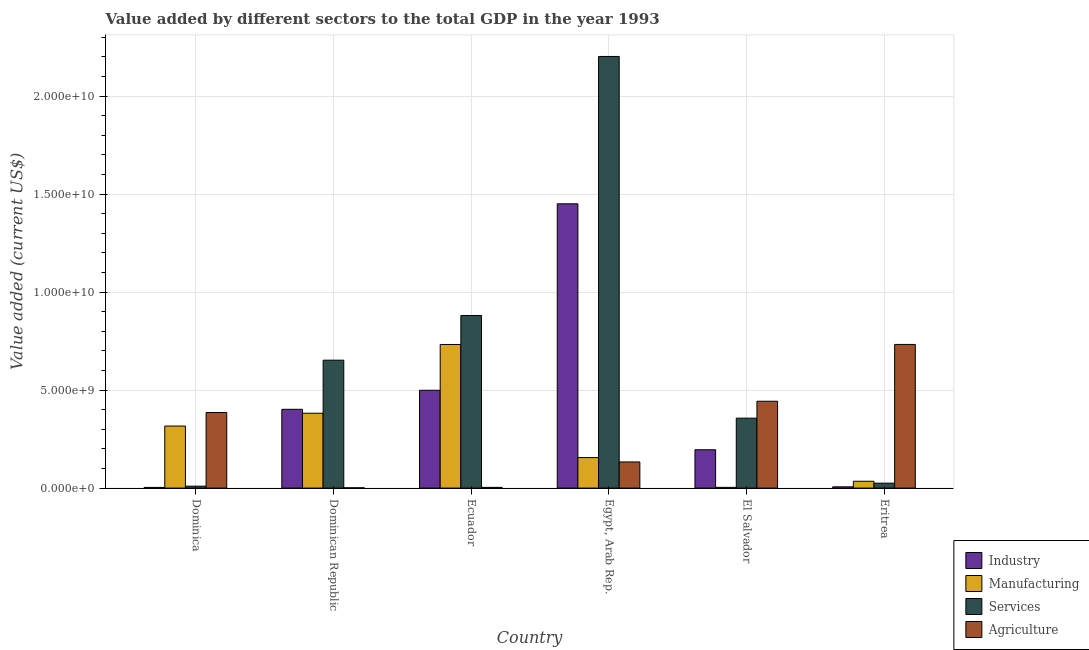How many groups of bars are there?
Offer a terse response. 6. Are the number of bars per tick equal to the number of legend labels?
Provide a short and direct response. Yes. Are the number of bars on each tick of the X-axis equal?
Your response must be concise. Yes. How many bars are there on the 3rd tick from the right?
Your answer should be very brief. 4. What is the label of the 4th group of bars from the left?
Your answer should be compact. Egypt, Arab Rep. In how many cases, is the number of bars for a given country not equal to the number of legend labels?
Your response must be concise. 0. What is the value added by industrial sector in Ecuador?
Provide a short and direct response. 4.99e+09. Across all countries, what is the maximum value added by industrial sector?
Keep it short and to the point. 1.45e+1. Across all countries, what is the minimum value added by industrial sector?
Keep it short and to the point. 3.49e+07. In which country was the value added by agricultural sector maximum?
Give a very brief answer. Eritrea. In which country was the value added by industrial sector minimum?
Provide a succinct answer. Dominica. What is the total value added by manufacturing sector in the graph?
Your answer should be very brief. 1.63e+1. What is the difference between the value added by agricultural sector in Egypt, Arab Rep. and that in Eritrea?
Ensure brevity in your answer.  -6.00e+09. What is the difference between the value added by agricultural sector in Dominica and the value added by manufacturing sector in Eritrea?
Provide a short and direct response. 3.51e+09. What is the average value added by manufacturing sector per country?
Your response must be concise. 2.71e+09. What is the difference between the value added by services sector and value added by agricultural sector in Egypt, Arab Rep.?
Provide a succinct answer. 2.07e+1. In how many countries, is the value added by industrial sector greater than 4000000000 US$?
Ensure brevity in your answer.  3. What is the ratio of the value added by agricultural sector in Dominican Republic to that in Ecuador?
Make the answer very short. 0.4. Is the value added by industrial sector in Ecuador less than that in El Salvador?
Make the answer very short. No. Is the difference between the value added by manufacturing sector in Ecuador and El Salvador greater than the difference between the value added by industrial sector in Ecuador and El Salvador?
Make the answer very short. Yes. What is the difference between the highest and the second highest value added by services sector?
Your answer should be compact. 1.32e+1. What is the difference between the highest and the lowest value added by industrial sector?
Give a very brief answer. 1.45e+1. Is it the case that in every country, the sum of the value added by industrial sector and value added by manufacturing sector is greater than the sum of value added by services sector and value added by agricultural sector?
Ensure brevity in your answer.  No. What does the 3rd bar from the left in Egypt, Arab Rep. represents?
Your response must be concise. Services. What does the 2nd bar from the right in Eritrea represents?
Your answer should be compact. Services. Is it the case that in every country, the sum of the value added by industrial sector and value added by manufacturing sector is greater than the value added by services sector?
Your response must be concise. No. Are all the bars in the graph horizontal?
Offer a very short reply. No. Does the graph contain any zero values?
Your answer should be compact. No. Does the graph contain grids?
Provide a short and direct response. Yes. Where does the legend appear in the graph?
Make the answer very short. Bottom right. How many legend labels are there?
Provide a succinct answer. 4. How are the legend labels stacked?
Your answer should be compact. Vertical. What is the title of the graph?
Your answer should be very brief. Value added by different sectors to the total GDP in the year 1993. What is the label or title of the X-axis?
Offer a very short reply. Country. What is the label or title of the Y-axis?
Give a very brief answer. Value added (current US$). What is the Value added (current US$) in Industry in Dominica?
Ensure brevity in your answer.  3.49e+07. What is the Value added (current US$) of Manufacturing in Dominica?
Your response must be concise. 3.17e+09. What is the Value added (current US$) in Services in Dominica?
Your answer should be compact. 9.78e+07. What is the Value added (current US$) of Agriculture in Dominica?
Your answer should be compact. 3.86e+09. What is the Value added (current US$) of Industry in Dominican Republic?
Make the answer very short. 4.02e+09. What is the Value added (current US$) in Manufacturing in Dominican Republic?
Offer a terse response. 3.82e+09. What is the Value added (current US$) in Services in Dominican Republic?
Your answer should be very brief. 6.53e+09. What is the Value added (current US$) in Agriculture in Dominican Republic?
Ensure brevity in your answer.  1.46e+07. What is the Value added (current US$) of Industry in Ecuador?
Your answer should be very brief. 4.99e+09. What is the Value added (current US$) in Manufacturing in Ecuador?
Your answer should be compact. 7.33e+09. What is the Value added (current US$) in Services in Ecuador?
Make the answer very short. 8.81e+09. What is the Value added (current US$) of Agriculture in Ecuador?
Keep it short and to the point. 3.63e+07. What is the Value added (current US$) of Industry in Egypt, Arab Rep.?
Provide a succinct answer. 1.45e+1. What is the Value added (current US$) of Manufacturing in Egypt, Arab Rep.?
Provide a short and direct response. 1.56e+09. What is the Value added (current US$) of Services in Egypt, Arab Rep.?
Your response must be concise. 2.20e+1. What is the Value added (current US$) of Agriculture in Egypt, Arab Rep.?
Your response must be concise. 1.33e+09. What is the Value added (current US$) in Industry in El Salvador?
Ensure brevity in your answer.  1.96e+09. What is the Value added (current US$) of Manufacturing in El Salvador?
Your response must be concise. 3.66e+07. What is the Value added (current US$) of Services in El Salvador?
Your answer should be compact. 3.57e+09. What is the Value added (current US$) in Agriculture in El Salvador?
Give a very brief answer. 4.43e+09. What is the Value added (current US$) of Industry in Eritrea?
Keep it short and to the point. 6.37e+07. What is the Value added (current US$) in Manufacturing in Eritrea?
Ensure brevity in your answer.  3.48e+08. What is the Value added (current US$) in Services in Eritrea?
Ensure brevity in your answer.  2.51e+08. What is the Value added (current US$) of Agriculture in Eritrea?
Offer a terse response. 7.33e+09. Across all countries, what is the maximum Value added (current US$) in Industry?
Give a very brief answer. 1.45e+1. Across all countries, what is the maximum Value added (current US$) in Manufacturing?
Keep it short and to the point. 7.33e+09. Across all countries, what is the maximum Value added (current US$) in Services?
Ensure brevity in your answer.  2.20e+1. Across all countries, what is the maximum Value added (current US$) of Agriculture?
Your answer should be compact. 7.33e+09. Across all countries, what is the minimum Value added (current US$) of Industry?
Offer a very short reply. 3.49e+07. Across all countries, what is the minimum Value added (current US$) in Manufacturing?
Your answer should be compact. 3.66e+07. Across all countries, what is the minimum Value added (current US$) in Services?
Your response must be concise. 9.78e+07. Across all countries, what is the minimum Value added (current US$) of Agriculture?
Make the answer very short. 1.46e+07. What is the total Value added (current US$) of Industry in the graph?
Make the answer very short. 2.56e+1. What is the total Value added (current US$) of Manufacturing in the graph?
Provide a short and direct response. 1.63e+1. What is the total Value added (current US$) of Services in the graph?
Offer a very short reply. 4.13e+1. What is the total Value added (current US$) in Agriculture in the graph?
Offer a very short reply. 1.70e+1. What is the difference between the Value added (current US$) of Industry in Dominica and that in Dominican Republic?
Offer a terse response. -3.99e+09. What is the difference between the Value added (current US$) of Manufacturing in Dominica and that in Dominican Republic?
Your response must be concise. -6.54e+08. What is the difference between the Value added (current US$) of Services in Dominica and that in Dominican Republic?
Your answer should be compact. -6.43e+09. What is the difference between the Value added (current US$) of Agriculture in Dominica and that in Dominican Republic?
Offer a very short reply. 3.84e+09. What is the difference between the Value added (current US$) in Industry in Dominica and that in Ecuador?
Keep it short and to the point. -4.96e+09. What is the difference between the Value added (current US$) in Manufacturing in Dominica and that in Ecuador?
Offer a terse response. -4.16e+09. What is the difference between the Value added (current US$) of Services in Dominica and that in Ecuador?
Offer a terse response. -8.71e+09. What is the difference between the Value added (current US$) in Agriculture in Dominica and that in Ecuador?
Your answer should be very brief. 3.82e+09. What is the difference between the Value added (current US$) in Industry in Dominica and that in Egypt, Arab Rep.?
Make the answer very short. -1.45e+1. What is the difference between the Value added (current US$) of Manufacturing in Dominica and that in Egypt, Arab Rep.?
Give a very brief answer. 1.61e+09. What is the difference between the Value added (current US$) in Services in Dominica and that in Egypt, Arab Rep.?
Ensure brevity in your answer.  -2.19e+1. What is the difference between the Value added (current US$) in Agriculture in Dominica and that in Egypt, Arab Rep.?
Make the answer very short. 2.52e+09. What is the difference between the Value added (current US$) of Industry in Dominica and that in El Salvador?
Offer a terse response. -1.92e+09. What is the difference between the Value added (current US$) of Manufacturing in Dominica and that in El Salvador?
Your response must be concise. 3.13e+09. What is the difference between the Value added (current US$) of Services in Dominica and that in El Salvador?
Ensure brevity in your answer.  -3.47e+09. What is the difference between the Value added (current US$) in Agriculture in Dominica and that in El Salvador?
Provide a succinct answer. -5.75e+08. What is the difference between the Value added (current US$) in Industry in Dominica and that in Eritrea?
Your response must be concise. -2.88e+07. What is the difference between the Value added (current US$) in Manufacturing in Dominica and that in Eritrea?
Keep it short and to the point. 2.82e+09. What is the difference between the Value added (current US$) in Services in Dominica and that in Eritrea?
Provide a short and direct response. -1.53e+08. What is the difference between the Value added (current US$) in Agriculture in Dominica and that in Eritrea?
Keep it short and to the point. -3.47e+09. What is the difference between the Value added (current US$) in Industry in Dominican Republic and that in Ecuador?
Keep it short and to the point. -9.72e+08. What is the difference between the Value added (current US$) of Manufacturing in Dominican Republic and that in Ecuador?
Provide a succinct answer. -3.51e+09. What is the difference between the Value added (current US$) in Services in Dominican Republic and that in Ecuador?
Offer a very short reply. -2.28e+09. What is the difference between the Value added (current US$) of Agriculture in Dominican Republic and that in Ecuador?
Your response must be concise. -2.17e+07. What is the difference between the Value added (current US$) of Industry in Dominican Republic and that in Egypt, Arab Rep.?
Your response must be concise. -1.05e+1. What is the difference between the Value added (current US$) of Manufacturing in Dominican Republic and that in Egypt, Arab Rep.?
Your response must be concise. 2.26e+09. What is the difference between the Value added (current US$) of Services in Dominican Republic and that in Egypt, Arab Rep.?
Make the answer very short. -1.55e+1. What is the difference between the Value added (current US$) in Agriculture in Dominican Republic and that in Egypt, Arab Rep.?
Your response must be concise. -1.32e+09. What is the difference between the Value added (current US$) in Industry in Dominican Republic and that in El Salvador?
Give a very brief answer. 2.06e+09. What is the difference between the Value added (current US$) in Manufacturing in Dominican Republic and that in El Salvador?
Your answer should be compact. 3.78e+09. What is the difference between the Value added (current US$) in Services in Dominican Republic and that in El Salvador?
Offer a terse response. 2.96e+09. What is the difference between the Value added (current US$) in Agriculture in Dominican Republic and that in El Salvador?
Keep it short and to the point. -4.42e+09. What is the difference between the Value added (current US$) of Industry in Dominican Republic and that in Eritrea?
Your response must be concise. 3.96e+09. What is the difference between the Value added (current US$) in Manufacturing in Dominican Republic and that in Eritrea?
Your response must be concise. 3.47e+09. What is the difference between the Value added (current US$) in Services in Dominican Republic and that in Eritrea?
Provide a succinct answer. 6.28e+09. What is the difference between the Value added (current US$) of Agriculture in Dominican Republic and that in Eritrea?
Your response must be concise. -7.32e+09. What is the difference between the Value added (current US$) of Industry in Ecuador and that in Egypt, Arab Rep.?
Your answer should be compact. -9.51e+09. What is the difference between the Value added (current US$) of Manufacturing in Ecuador and that in Egypt, Arab Rep.?
Ensure brevity in your answer.  5.77e+09. What is the difference between the Value added (current US$) in Services in Ecuador and that in Egypt, Arab Rep.?
Give a very brief answer. -1.32e+1. What is the difference between the Value added (current US$) of Agriculture in Ecuador and that in Egypt, Arab Rep.?
Make the answer very short. -1.30e+09. What is the difference between the Value added (current US$) of Industry in Ecuador and that in El Salvador?
Your answer should be compact. 3.04e+09. What is the difference between the Value added (current US$) of Manufacturing in Ecuador and that in El Salvador?
Provide a succinct answer. 7.29e+09. What is the difference between the Value added (current US$) of Services in Ecuador and that in El Salvador?
Give a very brief answer. 5.24e+09. What is the difference between the Value added (current US$) of Agriculture in Ecuador and that in El Salvador?
Your response must be concise. -4.40e+09. What is the difference between the Value added (current US$) of Industry in Ecuador and that in Eritrea?
Provide a succinct answer. 4.93e+09. What is the difference between the Value added (current US$) of Manufacturing in Ecuador and that in Eritrea?
Your answer should be compact. 6.98e+09. What is the difference between the Value added (current US$) in Services in Ecuador and that in Eritrea?
Provide a short and direct response. 8.56e+09. What is the difference between the Value added (current US$) of Agriculture in Ecuador and that in Eritrea?
Your response must be concise. -7.29e+09. What is the difference between the Value added (current US$) of Industry in Egypt, Arab Rep. and that in El Salvador?
Keep it short and to the point. 1.26e+1. What is the difference between the Value added (current US$) in Manufacturing in Egypt, Arab Rep. and that in El Salvador?
Your answer should be compact. 1.52e+09. What is the difference between the Value added (current US$) of Services in Egypt, Arab Rep. and that in El Salvador?
Offer a very short reply. 1.85e+1. What is the difference between the Value added (current US$) of Agriculture in Egypt, Arab Rep. and that in El Salvador?
Offer a terse response. -3.10e+09. What is the difference between the Value added (current US$) in Industry in Egypt, Arab Rep. and that in Eritrea?
Give a very brief answer. 1.44e+1. What is the difference between the Value added (current US$) of Manufacturing in Egypt, Arab Rep. and that in Eritrea?
Offer a terse response. 1.21e+09. What is the difference between the Value added (current US$) of Services in Egypt, Arab Rep. and that in Eritrea?
Ensure brevity in your answer.  2.18e+1. What is the difference between the Value added (current US$) in Agriculture in Egypt, Arab Rep. and that in Eritrea?
Keep it short and to the point. -6.00e+09. What is the difference between the Value added (current US$) in Industry in El Salvador and that in Eritrea?
Provide a short and direct response. 1.89e+09. What is the difference between the Value added (current US$) in Manufacturing in El Salvador and that in Eritrea?
Provide a succinct answer. -3.12e+08. What is the difference between the Value added (current US$) in Services in El Salvador and that in Eritrea?
Ensure brevity in your answer.  3.32e+09. What is the difference between the Value added (current US$) of Agriculture in El Salvador and that in Eritrea?
Give a very brief answer. -2.90e+09. What is the difference between the Value added (current US$) of Industry in Dominica and the Value added (current US$) of Manufacturing in Dominican Republic?
Offer a terse response. -3.79e+09. What is the difference between the Value added (current US$) of Industry in Dominica and the Value added (current US$) of Services in Dominican Republic?
Offer a very short reply. -6.49e+09. What is the difference between the Value added (current US$) of Industry in Dominica and the Value added (current US$) of Agriculture in Dominican Republic?
Make the answer very short. 2.03e+07. What is the difference between the Value added (current US$) in Manufacturing in Dominica and the Value added (current US$) in Services in Dominican Republic?
Provide a succinct answer. -3.36e+09. What is the difference between the Value added (current US$) of Manufacturing in Dominica and the Value added (current US$) of Agriculture in Dominican Republic?
Provide a short and direct response. 3.15e+09. What is the difference between the Value added (current US$) in Services in Dominica and the Value added (current US$) in Agriculture in Dominican Republic?
Give a very brief answer. 8.32e+07. What is the difference between the Value added (current US$) of Industry in Dominica and the Value added (current US$) of Manufacturing in Ecuador?
Offer a very short reply. -7.29e+09. What is the difference between the Value added (current US$) of Industry in Dominica and the Value added (current US$) of Services in Ecuador?
Keep it short and to the point. -8.77e+09. What is the difference between the Value added (current US$) in Industry in Dominica and the Value added (current US$) in Agriculture in Ecuador?
Offer a terse response. -1.41e+06. What is the difference between the Value added (current US$) in Manufacturing in Dominica and the Value added (current US$) in Services in Ecuador?
Offer a terse response. -5.64e+09. What is the difference between the Value added (current US$) in Manufacturing in Dominica and the Value added (current US$) in Agriculture in Ecuador?
Your answer should be compact. 3.13e+09. What is the difference between the Value added (current US$) of Services in Dominica and the Value added (current US$) of Agriculture in Ecuador?
Provide a short and direct response. 6.15e+07. What is the difference between the Value added (current US$) of Industry in Dominica and the Value added (current US$) of Manufacturing in Egypt, Arab Rep.?
Offer a very short reply. -1.52e+09. What is the difference between the Value added (current US$) in Industry in Dominica and the Value added (current US$) in Services in Egypt, Arab Rep.?
Your answer should be compact. -2.20e+1. What is the difference between the Value added (current US$) of Industry in Dominica and the Value added (current US$) of Agriculture in Egypt, Arab Rep.?
Give a very brief answer. -1.30e+09. What is the difference between the Value added (current US$) of Manufacturing in Dominica and the Value added (current US$) of Services in Egypt, Arab Rep.?
Give a very brief answer. -1.89e+1. What is the difference between the Value added (current US$) in Manufacturing in Dominica and the Value added (current US$) in Agriculture in Egypt, Arab Rep.?
Your answer should be compact. 1.83e+09. What is the difference between the Value added (current US$) of Services in Dominica and the Value added (current US$) of Agriculture in Egypt, Arab Rep.?
Give a very brief answer. -1.24e+09. What is the difference between the Value added (current US$) in Industry in Dominica and the Value added (current US$) in Manufacturing in El Salvador?
Keep it short and to the point. -1.76e+06. What is the difference between the Value added (current US$) in Industry in Dominica and the Value added (current US$) in Services in El Salvador?
Offer a terse response. -3.53e+09. What is the difference between the Value added (current US$) in Industry in Dominica and the Value added (current US$) in Agriculture in El Salvador?
Provide a succinct answer. -4.40e+09. What is the difference between the Value added (current US$) of Manufacturing in Dominica and the Value added (current US$) of Services in El Salvador?
Your answer should be compact. -4.02e+08. What is the difference between the Value added (current US$) of Manufacturing in Dominica and the Value added (current US$) of Agriculture in El Salvador?
Offer a very short reply. -1.27e+09. What is the difference between the Value added (current US$) of Services in Dominica and the Value added (current US$) of Agriculture in El Salvador?
Offer a terse response. -4.33e+09. What is the difference between the Value added (current US$) of Industry in Dominica and the Value added (current US$) of Manufacturing in Eritrea?
Provide a succinct answer. -3.14e+08. What is the difference between the Value added (current US$) in Industry in Dominica and the Value added (current US$) in Services in Eritrea?
Provide a short and direct response. -2.16e+08. What is the difference between the Value added (current US$) of Industry in Dominica and the Value added (current US$) of Agriculture in Eritrea?
Provide a succinct answer. -7.30e+09. What is the difference between the Value added (current US$) in Manufacturing in Dominica and the Value added (current US$) in Services in Eritrea?
Your response must be concise. 2.92e+09. What is the difference between the Value added (current US$) in Manufacturing in Dominica and the Value added (current US$) in Agriculture in Eritrea?
Keep it short and to the point. -4.16e+09. What is the difference between the Value added (current US$) of Services in Dominica and the Value added (current US$) of Agriculture in Eritrea?
Provide a succinct answer. -7.23e+09. What is the difference between the Value added (current US$) of Industry in Dominican Republic and the Value added (current US$) of Manufacturing in Ecuador?
Offer a very short reply. -3.31e+09. What is the difference between the Value added (current US$) in Industry in Dominican Republic and the Value added (current US$) in Services in Ecuador?
Provide a short and direct response. -4.79e+09. What is the difference between the Value added (current US$) in Industry in Dominican Republic and the Value added (current US$) in Agriculture in Ecuador?
Your response must be concise. 3.98e+09. What is the difference between the Value added (current US$) of Manufacturing in Dominican Republic and the Value added (current US$) of Services in Ecuador?
Make the answer very short. -4.99e+09. What is the difference between the Value added (current US$) in Manufacturing in Dominican Republic and the Value added (current US$) in Agriculture in Ecuador?
Offer a terse response. 3.78e+09. What is the difference between the Value added (current US$) in Services in Dominican Republic and the Value added (current US$) in Agriculture in Ecuador?
Your answer should be very brief. 6.49e+09. What is the difference between the Value added (current US$) of Industry in Dominican Republic and the Value added (current US$) of Manufacturing in Egypt, Arab Rep.?
Give a very brief answer. 2.46e+09. What is the difference between the Value added (current US$) in Industry in Dominican Republic and the Value added (current US$) in Services in Egypt, Arab Rep.?
Give a very brief answer. -1.80e+1. What is the difference between the Value added (current US$) of Industry in Dominican Republic and the Value added (current US$) of Agriculture in Egypt, Arab Rep.?
Give a very brief answer. 2.69e+09. What is the difference between the Value added (current US$) in Manufacturing in Dominican Republic and the Value added (current US$) in Services in Egypt, Arab Rep.?
Provide a short and direct response. -1.82e+1. What is the difference between the Value added (current US$) in Manufacturing in Dominican Republic and the Value added (current US$) in Agriculture in Egypt, Arab Rep.?
Your answer should be very brief. 2.49e+09. What is the difference between the Value added (current US$) of Services in Dominican Republic and the Value added (current US$) of Agriculture in Egypt, Arab Rep.?
Give a very brief answer. 5.19e+09. What is the difference between the Value added (current US$) in Industry in Dominican Republic and the Value added (current US$) in Manufacturing in El Salvador?
Keep it short and to the point. 3.98e+09. What is the difference between the Value added (current US$) of Industry in Dominican Republic and the Value added (current US$) of Services in El Salvador?
Your response must be concise. 4.52e+08. What is the difference between the Value added (current US$) in Industry in Dominican Republic and the Value added (current US$) in Agriculture in El Salvador?
Provide a succinct answer. -4.12e+08. What is the difference between the Value added (current US$) in Manufacturing in Dominican Republic and the Value added (current US$) in Services in El Salvador?
Your answer should be compact. 2.52e+08. What is the difference between the Value added (current US$) in Manufacturing in Dominican Republic and the Value added (current US$) in Agriculture in El Salvador?
Make the answer very short. -6.12e+08. What is the difference between the Value added (current US$) in Services in Dominican Republic and the Value added (current US$) in Agriculture in El Salvador?
Your response must be concise. 2.10e+09. What is the difference between the Value added (current US$) in Industry in Dominican Republic and the Value added (current US$) in Manufacturing in Eritrea?
Offer a terse response. 3.67e+09. What is the difference between the Value added (current US$) of Industry in Dominican Republic and the Value added (current US$) of Services in Eritrea?
Offer a very short reply. 3.77e+09. What is the difference between the Value added (current US$) in Industry in Dominican Republic and the Value added (current US$) in Agriculture in Eritrea?
Provide a succinct answer. -3.31e+09. What is the difference between the Value added (current US$) in Manufacturing in Dominican Republic and the Value added (current US$) in Services in Eritrea?
Provide a succinct answer. 3.57e+09. What is the difference between the Value added (current US$) in Manufacturing in Dominican Republic and the Value added (current US$) in Agriculture in Eritrea?
Ensure brevity in your answer.  -3.51e+09. What is the difference between the Value added (current US$) of Services in Dominican Republic and the Value added (current US$) of Agriculture in Eritrea?
Give a very brief answer. -8.03e+08. What is the difference between the Value added (current US$) in Industry in Ecuador and the Value added (current US$) in Manufacturing in Egypt, Arab Rep.?
Your response must be concise. 3.44e+09. What is the difference between the Value added (current US$) in Industry in Ecuador and the Value added (current US$) in Services in Egypt, Arab Rep.?
Your answer should be compact. -1.70e+1. What is the difference between the Value added (current US$) of Industry in Ecuador and the Value added (current US$) of Agriculture in Egypt, Arab Rep.?
Offer a terse response. 3.66e+09. What is the difference between the Value added (current US$) of Manufacturing in Ecuador and the Value added (current US$) of Services in Egypt, Arab Rep.?
Your answer should be compact. -1.47e+1. What is the difference between the Value added (current US$) of Manufacturing in Ecuador and the Value added (current US$) of Agriculture in Egypt, Arab Rep.?
Provide a short and direct response. 5.99e+09. What is the difference between the Value added (current US$) in Services in Ecuador and the Value added (current US$) in Agriculture in Egypt, Arab Rep.?
Your answer should be compact. 7.47e+09. What is the difference between the Value added (current US$) of Industry in Ecuador and the Value added (current US$) of Manufacturing in El Salvador?
Make the answer very short. 4.96e+09. What is the difference between the Value added (current US$) in Industry in Ecuador and the Value added (current US$) in Services in El Salvador?
Offer a terse response. 1.42e+09. What is the difference between the Value added (current US$) of Industry in Ecuador and the Value added (current US$) of Agriculture in El Salvador?
Your answer should be compact. 5.61e+08. What is the difference between the Value added (current US$) of Manufacturing in Ecuador and the Value added (current US$) of Services in El Salvador?
Keep it short and to the point. 3.76e+09. What is the difference between the Value added (current US$) of Manufacturing in Ecuador and the Value added (current US$) of Agriculture in El Salvador?
Your answer should be very brief. 2.90e+09. What is the difference between the Value added (current US$) in Services in Ecuador and the Value added (current US$) in Agriculture in El Salvador?
Give a very brief answer. 4.38e+09. What is the difference between the Value added (current US$) of Industry in Ecuador and the Value added (current US$) of Manufacturing in Eritrea?
Give a very brief answer. 4.64e+09. What is the difference between the Value added (current US$) in Industry in Ecuador and the Value added (current US$) in Services in Eritrea?
Give a very brief answer. 4.74e+09. What is the difference between the Value added (current US$) in Industry in Ecuador and the Value added (current US$) in Agriculture in Eritrea?
Offer a terse response. -2.34e+09. What is the difference between the Value added (current US$) of Manufacturing in Ecuador and the Value added (current US$) of Services in Eritrea?
Offer a very short reply. 7.08e+09. What is the difference between the Value added (current US$) in Manufacturing in Ecuador and the Value added (current US$) in Agriculture in Eritrea?
Keep it short and to the point. -2.10e+06. What is the difference between the Value added (current US$) of Services in Ecuador and the Value added (current US$) of Agriculture in Eritrea?
Keep it short and to the point. 1.48e+09. What is the difference between the Value added (current US$) in Industry in Egypt, Arab Rep. and the Value added (current US$) in Manufacturing in El Salvador?
Give a very brief answer. 1.45e+1. What is the difference between the Value added (current US$) of Industry in Egypt, Arab Rep. and the Value added (current US$) of Services in El Salvador?
Your answer should be compact. 1.09e+1. What is the difference between the Value added (current US$) of Industry in Egypt, Arab Rep. and the Value added (current US$) of Agriculture in El Salvador?
Offer a terse response. 1.01e+1. What is the difference between the Value added (current US$) of Manufacturing in Egypt, Arab Rep. and the Value added (current US$) of Services in El Salvador?
Provide a short and direct response. -2.01e+09. What is the difference between the Value added (current US$) of Manufacturing in Egypt, Arab Rep. and the Value added (current US$) of Agriculture in El Salvador?
Offer a terse response. -2.87e+09. What is the difference between the Value added (current US$) of Services in Egypt, Arab Rep. and the Value added (current US$) of Agriculture in El Salvador?
Keep it short and to the point. 1.76e+1. What is the difference between the Value added (current US$) in Industry in Egypt, Arab Rep. and the Value added (current US$) in Manufacturing in Eritrea?
Offer a terse response. 1.42e+1. What is the difference between the Value added (current US$) in Industry in Egypt, Arab Rep. and the Value added (current US$) in Services in Eritrea?
Your answer should be very brief. 1.43e+1. What is the difference between the Value added (current US$) of Industry in Egypt, Arab Rep. and the Value added (current US$) of Agriculture in Eritrea?
Your answer should be very brief. 7.18e+09. What is the difference between the Value added (current US$) of Manufacturing in Egypt, Arab Rep. and the Value added (current US$) of Services in Eritrea?
Offer a very short reply. 1.31e+09. What is the difference between the Value added (current US$) in Manufacturing in Egypt, Arab Rep. and the Value added (current US$) in Agriculture in Eritrea?
Ensure brevity in your answer.  -5.77e+09. What is the difference between the Value added (current US$) in Services in Egypt, Arab Rep. and the Value added (current US$) in Agriculture in Eritrea?
Offer a very short reply. 1.47e+1. What is the difference between the Value added (current US$) in Industry in El Salvador and the Value added (current US$) in Manufacturing in Eritrea?
Keep it short and to the point. 1.61e+09. What is the difference between the Value added (current US$) of Industry in El Salvador and the Value added (current US$) of Services in Eritrea?
Your answer should be compact. 1.71e+09. What is the difference between the Value added (current US$) of Industry in El Salvador and the Value added (current US$) of Agriculture in Eritrea?
Offer a very short reply. -5.37e+09. What is the difference between the Value added (current US$) in Manufacturing in El Salvador and the Value added (current US$) in Services in Eritrea?
Your answer should be very brief. -2.15e+08. What is the difference between the Value added (current US$) of Manufacturing in El Salvador and the Value added (current US$) of Agriculture in Eritrea?
Provide a short and direct response. -7.29e+09. What is the difference between the Value added (current US$) in Services in El Salvador and the Value added (current US$) in Agriculture in Eritrea?
Give a very brief answer. -3.76e+09. What is the average Value added (current US$) in Industry per country?
Your answer should be compact. 4.26e+09. What is the average Value added (current US$) in Manufacturing per country?
Your answer should be compact. 2.71e+09. What is the average Value added (current US$) in Services per country?
Your response must be concise. 6.88e+09. What is the average Value added (current US$) of Agriculture per country?
Make the answer very short. 2.83e+09. What is the difference between the Value added (current US$) of Industry and Value added (current US$) of Manufacturing in Dominica?
Ensure brevity in your answer.  -3.13e+09. What is the difference between the Value added (current US$) of Industry and Value added (current US$) of Services in Dominica?
Provide a short and direct response. -6.29e+07. What is the difference between the Value added (current US$) of Industry and Value added (current US$) of Agriculture in Dominica?
Give a very brief answer. -3.82e+09. What is the difference between the Value added (current US$) of Manufacturing and Value added (current US$) of Services in Dominica?
Your answer should be compact. 3.07e+09. What is the difference between the Value added (current US$) of Manufacturing and Value added (current US$) of Agriculture in Dominica?
Your answer should be very brief. -6.90e+08. What is the difference between the Value added (current US$) of Services and Value added (current US$) of Agriculture in Dominica?
Ensure brevity in your answer.  -3.76e+09. What is the difference between the Value added (current US$) of Industry and Value added (current US$) of Manufacturing in Dominican Republic?
Provide a short and direct response. 2.00e+08. What is the difference between the Value added (current US$) in Industry and Value added (current US$) in Services in Dominican Republic?
Your answer should be very brief. -2.51e+09. What is the difference between the Value added (current US$) of Industry and Value added (current US$) of Agriculture in Dominican Republic?
Your answer should be compact. 4.01e+09. What is the difference between the Value added (current US$) in Manufacturing and Value added (current US$) in Services in Dominican Republic?
Your answer should be compact. -2.71e+09. What is the difference between the Value added (current US$) in Manufacturing and Value added (current US$) in Agriculture in Dominican Republic?
Ensure brevity in your answer.  3.81e+09. What is the difference between the Value added (current US$) of Services and Value added (current US$) of Agriculture in Dominican Republic?
Your answer should be very brief. 6.51e+09. What is the difference between the Value added (current US$) of Industry and Value added (current US$) of Manufacturing in Ecuador?
Make the answer very short. -2.34e+09. What is the difference between the Value added (current US$) in Industry and Value added (current US$) in Services in Ecuador?
Your answer should be very brief. -3.81e+09. What is the difference between the Value added (current US$) in Industry and Value added (current US$) in Agriculture in Ecuador?
Provide a succinct answer. 4.96e+09. What is the difference between the Value added (current US$) in Manufacturing and Value added (current US$) in Services in Ecuador?
Provide a short and direct response. -1.48e+09. What is the difference between the Value added (current US$) of Manufacturing and Value added (current US$) of Agriculture in Ecuador?
Provide a succinct answer. 7.29e+09. What is the difference between the Value added (current US$) in Services and Value added (current US$) in Agriculture in Ecuador?
Your response must be concise. 8.77e+09. What is the difference between the Value added (current US$) in Industry and Value added (current US$) in Manufacturing in Egypt, Arab Rep.?
Make the answer very short. 1.30e+1. What is the difference between the Value added (current US$) of Industry and Value added (current US$) of Services in Egypt, Arab Rep.?
Your answer should be very brief. -7.52e+09. What is the difference between the Value added (current US$) of Industry and Value added (current US$) of Agriculture in Egypt, Arab Rep.?
Offer a very short reply. 1.32e+1. What is the difference between the Value added (current US$) in Manufacturing and Value added (current US$) in Services in Egypt, Arab Rep.?
Your answer should be very brief. -2.05e+1. What is the difference between the Value added (current US$) in Manufacturing and Value added (current US$) in Agriculture in Egypt, Arab Rep.?
Make the answer very short. 2.23e+08. What is the difference between the Value added (current US$) in Services and Value added (current US$) in Agriculture in Egypt, Arab Rep.?
Give a very brief answer. 2.07e+1. What is the difference between the Value added (current US$) of Industry and Value added (current US$) of Manufacturing in El Salvador?
Keep it short and to the point. 1.92e+09. What is the difference between the Value added (current US$) in Industry and Value added (current US$) in Services in El Salvador?
Ensure brevity in your answer.  -1.61e+09. What is the difference between the Value added (current US$) of Industry and Value added (current US$) of Agriculture in El Salvador?
Your answer should be very brief. -2.48e+09. What is the difference between the Value added (current US$) in Manufacturing and Value added (current US$) in Services in El Salvador?
Offer a terse response. -3.53e+09. What is the difference between the Value added (current US$) of Manufacturing and Value added (current US$) of Agriculture in El Salvador?
Make the answer very short. -4.40e+09. What is the difference between the Value added (current US$) in Services and Value added (current US$) in Agriculture in El Salvador?
Your answer should be compact. -8.64e+08. What is the difference between the Value added (current US$) of Industry and Value added (current US$) of Manufacturing in Eritrea?
Provide a succinct answer. -2.85e+08. What is the difference between the Value added (current US$) of Industry and Value added (current US$) of Services in Eritrea?
Your answer should be compact. -1.88e+08. What is the difference between the Value added (current US$) of Industry and Value added (current US$) of Agriculture in Eritrea?
Your response must be concise. -7.27e+09. What is the difference between the Value added (current US$) in Manufacturing and Value added (current US$) in Services in Eritrea?
Make the answer very short. 9.73e+07. What is the difference between the Value added (current US$) in Manufacturing and Value added (current US$) in Agriculture in Eritrea?
Your answer should be compact. -6.98e+09. What is the difference between the Value added (current US$) of Services and Value added (current US$) of Agriculture in Eritrea?
Ensure brevity in your answer.  -7.08e+09. What is the ratio of the Value added (current US$) in Industry in Dominica to that in Dominican Republic?
Give a very brief answer. 0.01. What is the ratio of the Value added (current US$) in Manufacturing in Dominica to that in Dominican Republic?
Offer a terse response. 0.83. What is the ratio of the Value added (current US$) of Services in Dominica to that in Dominican Republic?
Offer a very short reply. 0.01. What is the ratio of the Value added (current US$) in Agriculture in Dominica to that in Dominican Republic?
Ensure brevity in your answer.  264.07. What is the ratio of the Value added (current US$) of Industry in Dominica to that in Ecuador?
Keep it short and to the point. 0.01. What is the ratio of the Value added (current US$) in Manufacturing in Dominica to that in Ecuador?
Keep it short and to the point. 0.43. What is the ratio of the Value added (current US$) of Services in Dominica to that in Ecuador?
Keep it short and to the point. 0.01. What is the ratio of the Value added (current US$) in Agriculture in Dominica to that in Ecuador?
Your answer should be very brief. 106.25. What is the ratio of the Value added (current US$) of Industry in Dominica to that in Egypt, Arab Rep.?
Your answer should be compact. 0. What is the ratio of the Value added (current US$) in Manufacturing in Dominica to that in Egypt, Arab Rep.?
Your answer should be compact. 2.03. What is the ratio of the Value added (current US$) of Services in Dominica to that in Egypt, Arab Rep.?
Give a very brief answer. 0. What is the ratio of the Value added (current US$) of Agriculture in Dominica to that in Egypt, Arab Rep.?
Give a very brief answer. 2.89. What is the ratio of the Value added (current US$) of Industry in Dominica to that in El Salvador?
Provide a short and direct response. 0.02. What is the ratio of the Value added (current US$) in Manufacturing in Dominica to that in El Salvador?
Make the answer very short. 86.42. What is the ratio of the Value added (current US$) in Services in Dominica to that in El Salvador?
Offer a terse response. 0.03. What is the ratio of the Value added (current US$) of Agriculture in Dominica to that in El Salvador?
Give a very brief answer. 0.87. What is the ratio of the Value added (current US$) in Industry in Dominica to that in Eritrea?
Keep it short and to the point. 0.55. What is the ratio of the Value added (current US$) in Manufacturing in Dominica to that in Eritrea?
Your response must be concise. 9.09. What is the ratio of the Value added (current US$) in Services in Dominica to that in Eritrea?
Make the answer very short. 0.39. What is the ratio of the Value added (current US$) of Agriculture in Dominica to that in Eritrea?
Keep it short and to the point. 0.53. What is the ratio of the Value added (current US$) of Industry in Dominican Republic to that in Ecuador?
Your answer should be compact. 0.81. What is the ratio of the Value added (current US$) in Manufacturing in Dominican Republic to that in Ecuador?
Give a very brief answer. 0.52. What is the ratio of the Value added (current US$) of Services in Dominican Republic to that in Ecuador?
Keep it short and to the point. 0.74. What is the ratio of the Value added (current US$) in Agriculture in Dominican Republic to that in Ecuador?
Your answer should be compact. 0.4. What is the ratio of the Value added (current US$) of Industry in Dominican Republic to that in Egypt, Arab Rep.?
Make the answer very short. 0.28. What is the ratio of the Value added (current US$) of Manufacturing in Dominican Republic to that in Egypt, Arab Rep.?
Give a very brief answer. 2.45. What is the ratio of the Value added (current US$) in Services in Dominican Republic to that in Egypt, Arab Rep.?
Your response must be concise. 0.3. What is the ratio of the Value added (current US$) in Agriculture in Dominican Republic to that in Egypt, Arab Rep.?
Offer a very short reply. 0.01. What is the ratio of the Value added (current US$) of Industry in Dominican Republic to that in El Salvador?
Your response must be concise. 2.06. What is the ratio of the Value added (current US$) of Manufacturing in Dominican Republic to that in El Salvador?
Ensure brevity in your answer.  104.27. What is the ratio of the Value added (current US$) in Services in Dominican Republic to that in El Salvador?
Give a very brief answer. 1.83. What is the ratio of the Value added (current US$) of Agriculture in Dominican Republic to that in El Salvador?
Offer a very short reply. 0. What is the ratio of the Value added (current US$) in Industry in Dominican Republic to that in Eritrea?
Your answer should be compact. 63.14. What is the ratio of the Value added (current US$) in Manufacturing in Dominican Republic to that in Eritrea?
Ensure brevity in your answer.  10.96. What is the ratio of the Value added (current US$) of Services in Dominican Republic to that in Eritrea?
Provide a short and direct response. 25.98. What is the ratio of the Value added (current US$) in Agriculture in Dominican Republic to that in Eritrea?
Offer a terse response. 0. What is the ratio of the Value added (current US$) in Industry in Ecuador to that in Egypt, Arab Rep.?
Your answer should be very brief. 0.34. What is the ratio of the Value added (current US$) in Manufacturing in Ecuador to that in Egypt, Arab Rep.?
Make the answer very short. 4.71. What is the ratio of the Value added (current US$) in Services in Ecuador to that in Egypt, Arab Rep.?
Offer a very short reply. 0.4. What is the ratio of the Value added (current US$) of Agriculture in Ecuador to that in Egypt, Arab Rep.?
Give a very brief answer. 0.03. What is the ratio of the Value added (current US$) in Industry in Ecuador to that in El Salvador?
Provide a short and direct response. 2.55. What is the ratio of the Value added (current US$) of Manufacturing in Ecuador to that in El Salvador?
Offer a terse response. 200.02. What is the ratio of the Value added (current US$) in Services in Ecuador to that in El Salvador?
Your answer should be compact. 2.47. What is the ratio of the Value added (current US$) in Agriculture in Ecuador to that in El Salvador?
Ensure brevity in your answer.  0.01. What is the ratio of the Value added (current US$) in Industry in Ecuador to that in Eritrea?
Make the answer very short. 78.4. What is the ratio of the Value added (current US$) of Manufacturing in Ecuador to that in Eritrea?
Your response must be concise. 21.03. What is the ratio of the Value added (current US$) in Services in Ecuador to that in Eritrea?
Provide a short and direct response. 35.06. What is the ratio of the Value added (current US$) in Agriculture in Ecuador to that in Eritrea?
Provide a short and direct response. 0.01. What is the ratio of the Value added (current US$) of Industry in Egypt, Arab Rep. to that in El Salvador?
Your answer should be very brief. 7.42. What is the ratio of the Value added (current US$) in Manufacturing in Egypt, Arab Rep. to that in El Salvador?
Ensure brevity in your answer.  42.5. What is the ratio of the Value added (current US$) in Services in Egypt, Arab Rep. to that in El Salvador?
Keep it short and to the point. 6.17. What is the ratio of the Value added (current US$) of Agriculture in Egypt, Arab Rep. to that in El Salvador?
Ensure brevity in your answer.  0.3. What is the ratio of the Value added (current US$) in Industry in Egypt, Arab Rep. to that in Eritrea?
Offer a very short reply. 227.82. What is the ratio of the Value added (current US$) of Manufacturing in Egypt, Arab Rep. to that in Eritrea?
Provide a succinct answer. 4.47. What is the ratio of the Value added (current US$) of Services in Egypt, Arab Rep. to that in Eritrea?
Make the answer very short. 87.68. What is the ratio of the Value added (current US$) of Agriculture in Egypt, Arab Rep. to that in Eritrea?
Ensure brevity in your answer.  0.18. What is the ratio of the Value added (current US$) of Industry in El Salvador to that in Eritrea?
Keep it short and to the point. 30.72. What is the ratio of the Value added (current US$) of Manufacturing in El Salvador to that in Eritrea?
Offer a very short reply. 0.11. What is the ratio of the Value added (current US$) in Services in El Salvador to that in Eritrea?
Your answer should be very brief. 14.2. What is the ratio of the Value added (current US$) of Agriculture in El Salvador to that in Eritrea?
Provide a succinct answer. 0.6. What is the difference between the highest and the second highest Value added (current US$) of Industry?
Your answer should be compact. 9.51e+09. What is the difference between the highest and the second highest Value added (current US$) in Manufacturing?
Provide a short and direct response. 3.51e+09. What is the difference between the highest and the second highest Value added (current US$) of Services?
Offer a very short reply. 1.32e+1. What is the difference between the highest and the second highest Value added (current US$) in Agriculture?
Ensure brevity in your answer.  2.90e+09. What is the difference between the highest and the lowest Value added (current US$) of Industry?
Make the answer very short. 1.45e+1. What is the difference between the highest and the lowest Value added (current US$) of Manufacturing?
Keep it short and to the point. 7.29e+09. What is the difference between the highest and the lowest Value added (current US$) of Services?
Provide a short and direct response. 2.19e+1. What is the difference between the highest and the lowest Value added (current US$) in Agriculture?
Provide a short and direct response. 7.32e+09. 